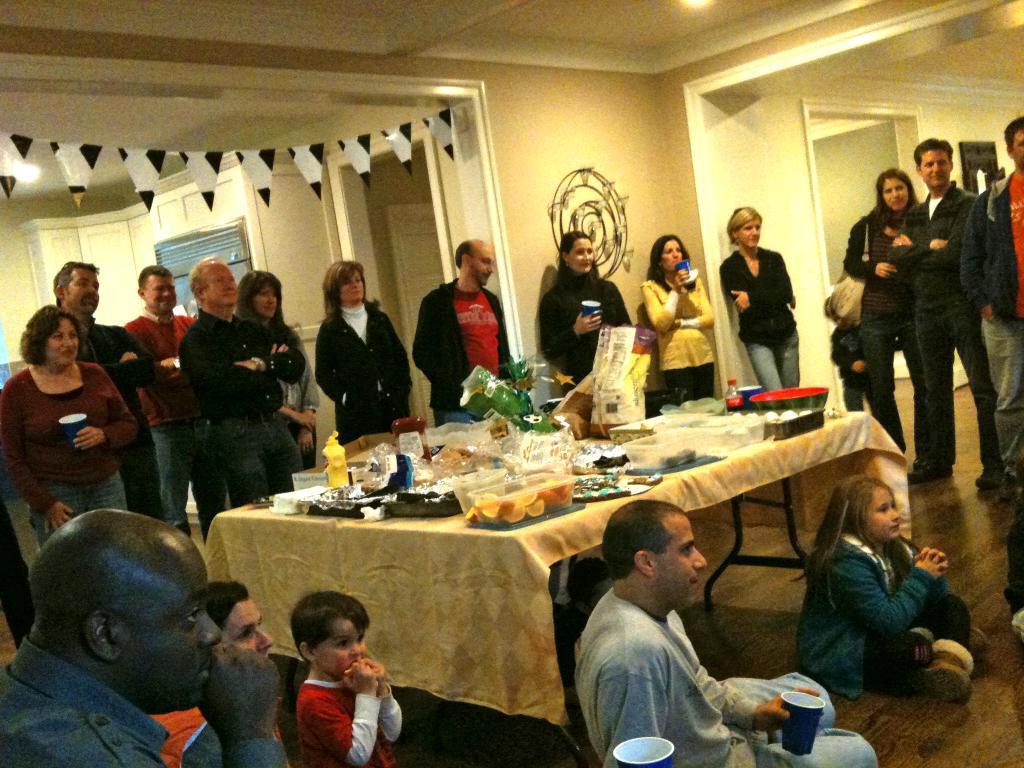Can you describe this image briefly? This image is taken inside a room. At the background there is a walls with doors. At the top of the image there is a roof and lights. At the bottom of the image there is a floor. In the middle of the image there is a table with a table cloth on it and there were few things on it like food items, bowls, plates. There were many people in this room standing and looking at each other 